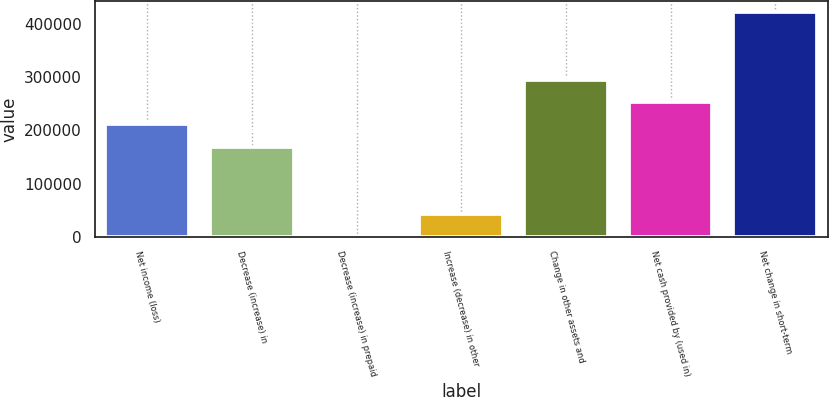Convert chart to OTSL. <chart><loc_0><loc_0><loc_500><loc_500><bar_chart><fcel>Net income (loss)<fcel>Decrease (increase) in<fcel>Decrease (increase) in prepaid<fcel>Increase (decrease) in other<fcel>Change in other assets and<fcel>Net cash provided by (used in)<fcel>Net change in short-term<nl><fcel>211228<fcel>169174<fcel>956<fcel>43010.4<fcel>295337<fcel>253282<fcel>421500<nl></chart> 